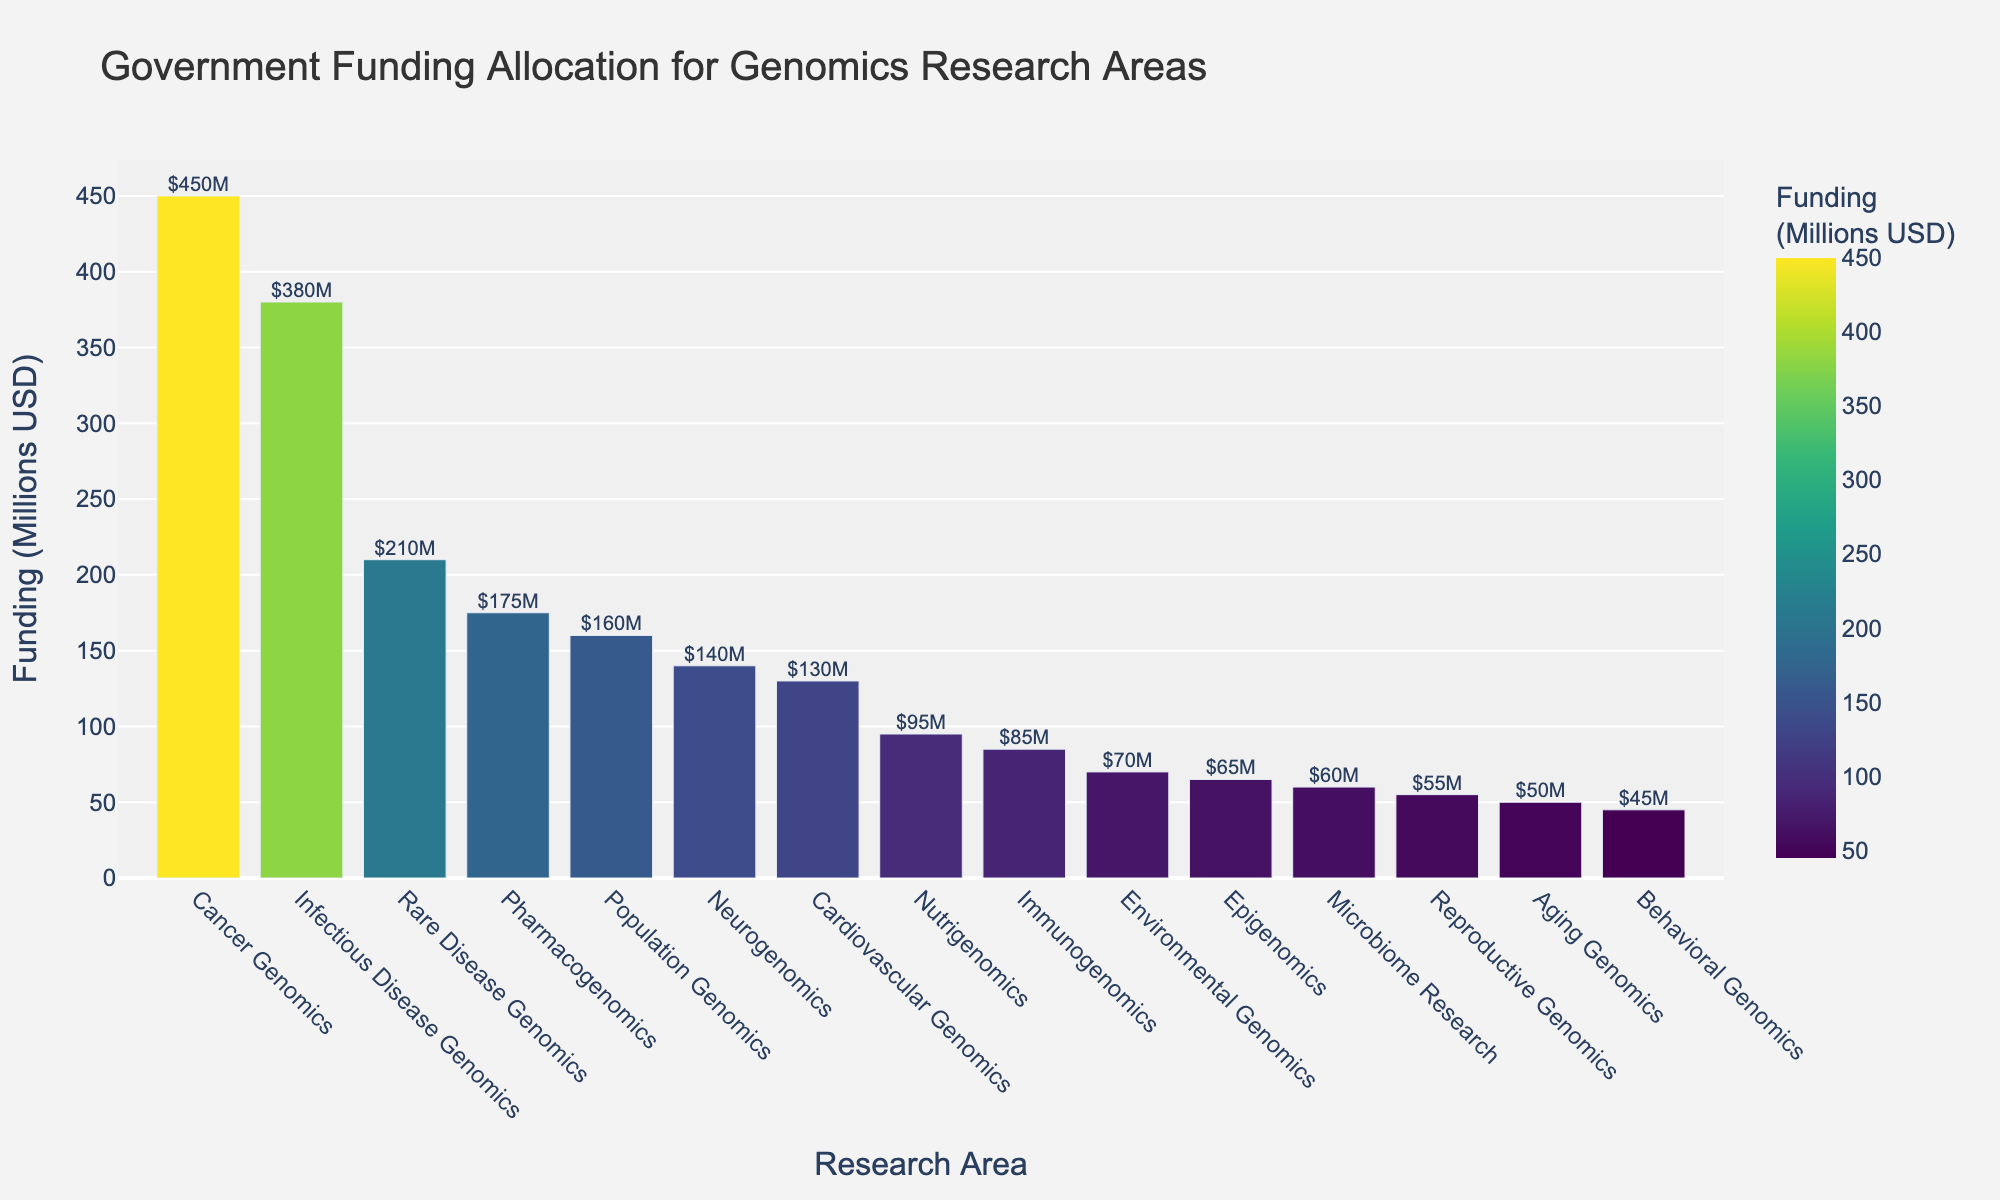Which genomics research area received the highest government funding? The highest bar corresponds to Cancer Genomics with a funding of $450 million.
Answer: Cancer Genomics Which genomics research area received the least government funding? The shortest bar corresponds to Behavioral Genomics with a funding of $45 million.
Answer: Behavioral Genomics Which research areas received more than $200 million? The bars for Cancer Genomics ($450M) and Infectious Disease Genomics ($380M) are above the $200 million mark, with Rare Disease Genomics ($210M) also surpassing this threshold.
Answer: Cancer Genomics, Infectious Disease Genomics, Rare Disease Genomics What is the total funding for the three least funded research areas? The funding for the three least funded areas are: Behavioral Genomics ($45M), Aging Genomics ($50M), and Reproductive Genomics ($55M). Adding them: 45 + 50 + 55 = 150
Answer: $150 million By how much does funding for Cancer Genomics exceed funding for Neurogenomics? Cancer Genomics received $450 million and Neurogenomics received $140 million. The difference is 450 - 140 = 310.
Answer: $310 million How does the funding for Population Genomics compare to Pharmacogenomics? Population Genomics received $160 million, while Pharmacogenomics received $175 million, meaning Pharmacogenomics received more funding.
Answer: Pharmacogenomics received more Which genomics research areas fall in the funding range of $50 million to $100 million? The bars corresponding to Cardiovascular Genomics ($130M), Nutrigenomics ($95M), Immunogenomics ($85M), Environmental Genomics ($70M), Epigenomics ($65M), Microbiome Research ($60M), and Aging Genomics ($50M) are in this range.
Answer: Nutrigenomics, Immunogenomics, Environmental Genomics, Epigenomics, Microbiome Research, Aging Genomics If funding for each area was increased by 10%, how much additional funding would Cancer Genomics receive? The current funding for Cancer Genomics is $450 million. A 10% increase would be 450 * 0.10 = 45.
Answer: $45 million What is the total funding allocated to genomics research? Adding up all the funding values: 450 + 380 + 210 + 175 + 160 + 140 + 130 + 95 + 85 + 70 + 65 + 60 + 55 + 50 + 45 = 2170
Answer: $2,170 million 